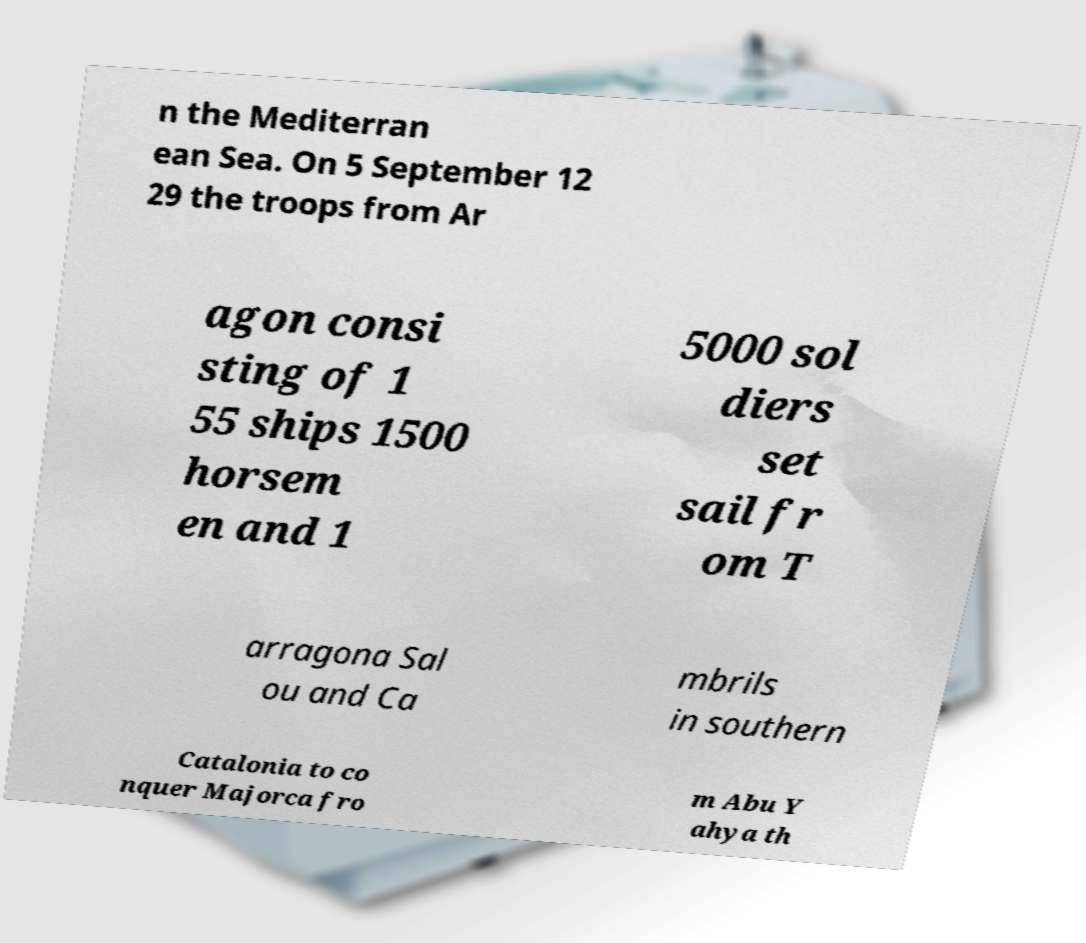Can you accurately transcribe the text from the provided image for me? n the Mediterran ean Sea. On 5 September 12 29 the troops from Ar agon consi sting of 1 55 ships 1500 horsem en and 1 5000 sol diers set sail fr om T arragona Sal ou and Ca mbrils in southern Catalonia to co nquer Majorca fro m Abu Y ahya th 